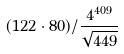<formula> <loc_0><loc_0><loc_500><loc_500>( 1 2 2 \cdot 8 0 ) / \frac { 4 ^ { 4 0 9 } } { \sqrt { 4 4 9 } }</formula> 